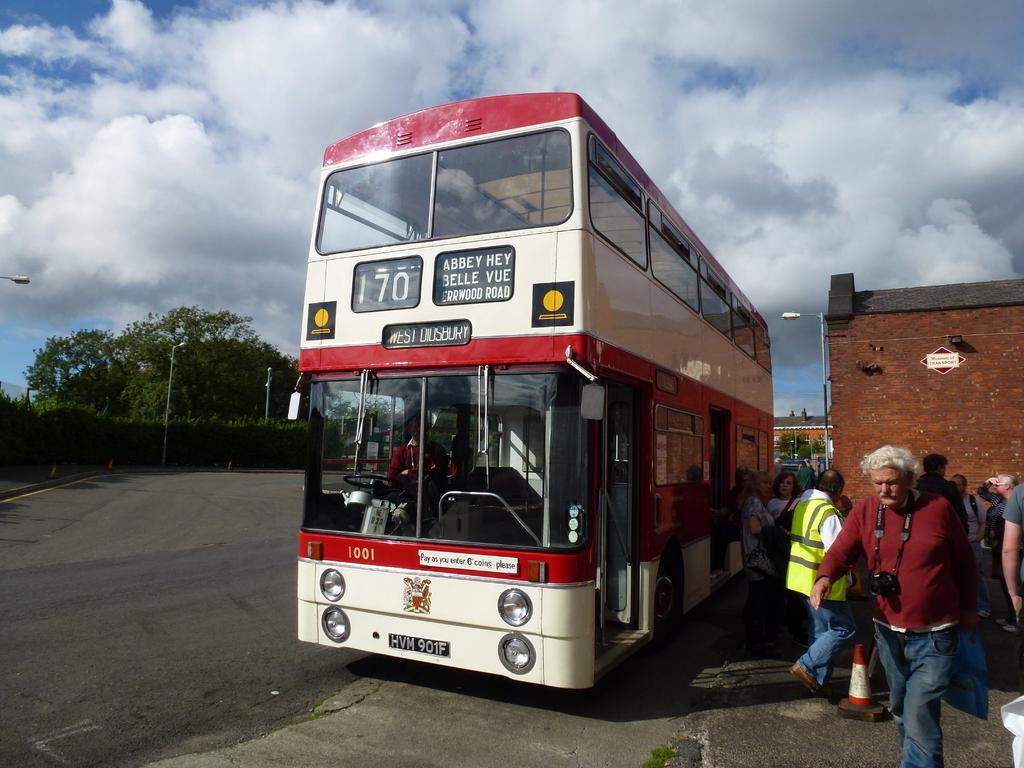<image>
Provide a brief description of the given image. double decker bus that read number 170 with people at the bottom 